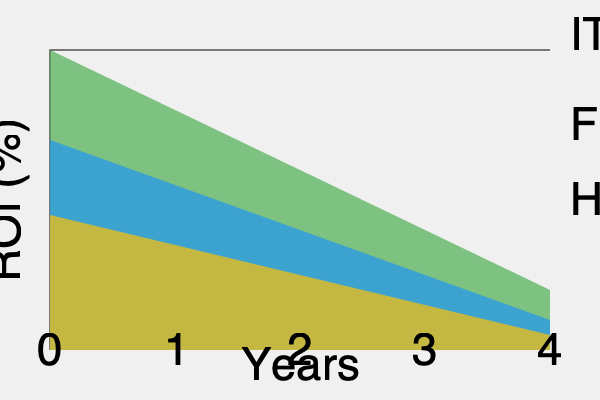Based on the stacked area chart showing the ROI of fraud prevention measures across different departments over a 4-year period, which department consistently demonstrates the highest ROI, and what is the approximate total ROI percentage for all departments combined by the end of year 4? To answer this question, we need to analyze the stacked area chart:

1. Identify the departments:
   - Bottom layer (green): IT
   - Middle layer (blue): Finance
   - Top layer (yellow): HR

2. Assess ROI trends:
   - IT has the largest area, indicating the highest ROI throughout the period.
   - Finance shows moderate ROI growth.
   - HR has the smallest area, suggesting the lowest ROI.

3. Evaluate consistency:
   IT maintains the largest area across all years, demonstrating consistent high ROI.

4. Calculate total ROI at year 4:
   - Estimate the height of each layer at the right edge of the chart (year 4).
   - IT: approximately 60%
   - Finance: approximately 30%
   - HR: approximately 15%
   - Total: 60% + 30% + 15% = 105%

Therefore, IT consistently demonstrates the highest ROI, and the approximate total ROI percentage for all departments combined by the end of year 4 is 105%.
Answer: IT; 105% 